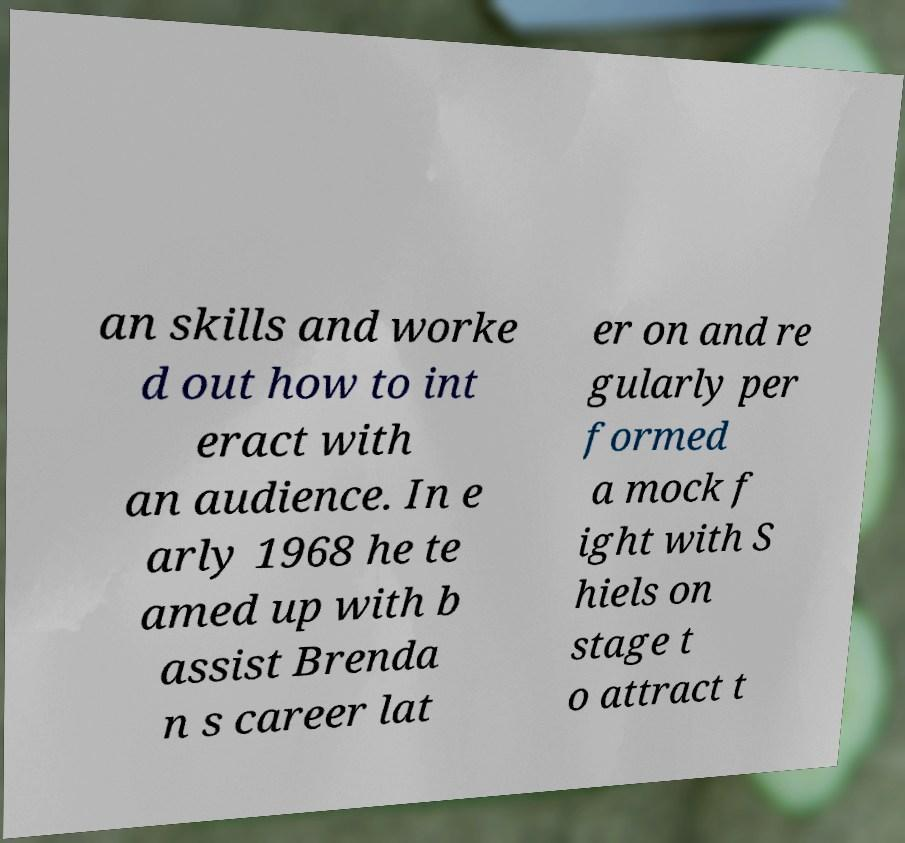I need the written content from this picture converted into text. Can you do that? an skills and worke d out how to int eract with an audience. In e arly 1968 he te amed up with b assist Brenda n s career lat er on and re gularly per formed a mock f ight with S hiels on stage t o attract t 